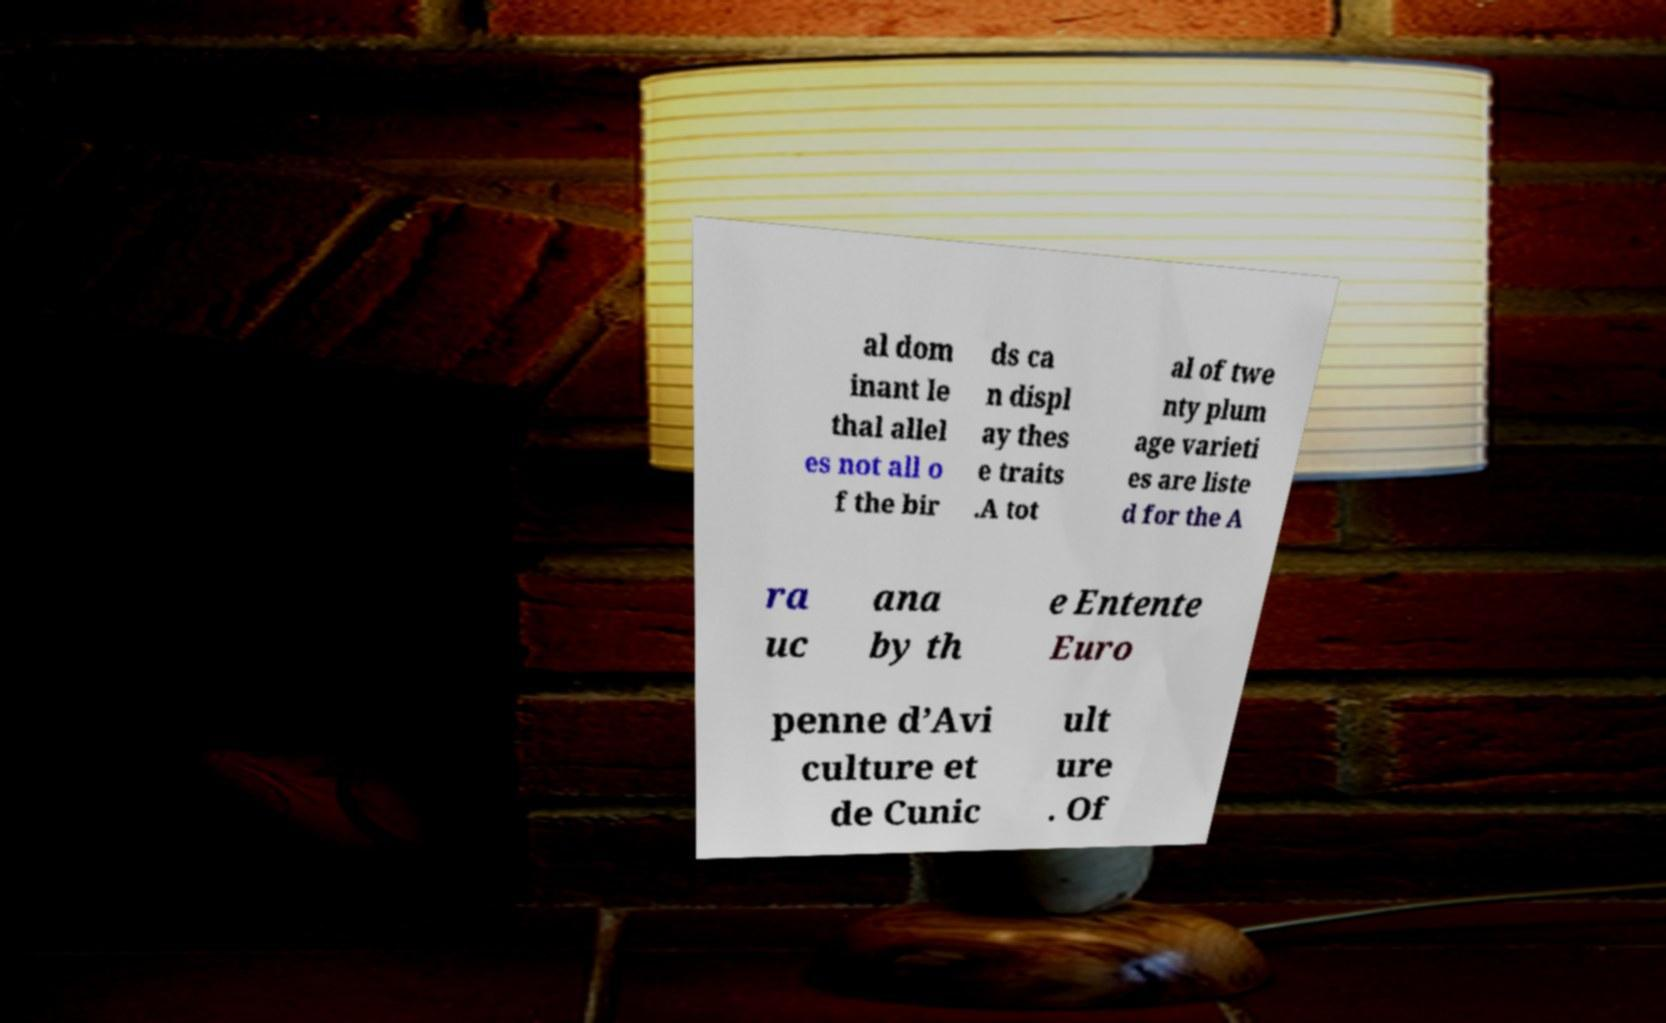Can you accurately transcribe the text from the provided image for me? al dom inant le thal allel es not all o f the bir ds ca n displ ay thes e traits .A tot al of twe nty plum age varieti es are liste d for the A ra uc ana by th e Entente Euro penne d’Avi culture et de Cunic ult ure . Of 